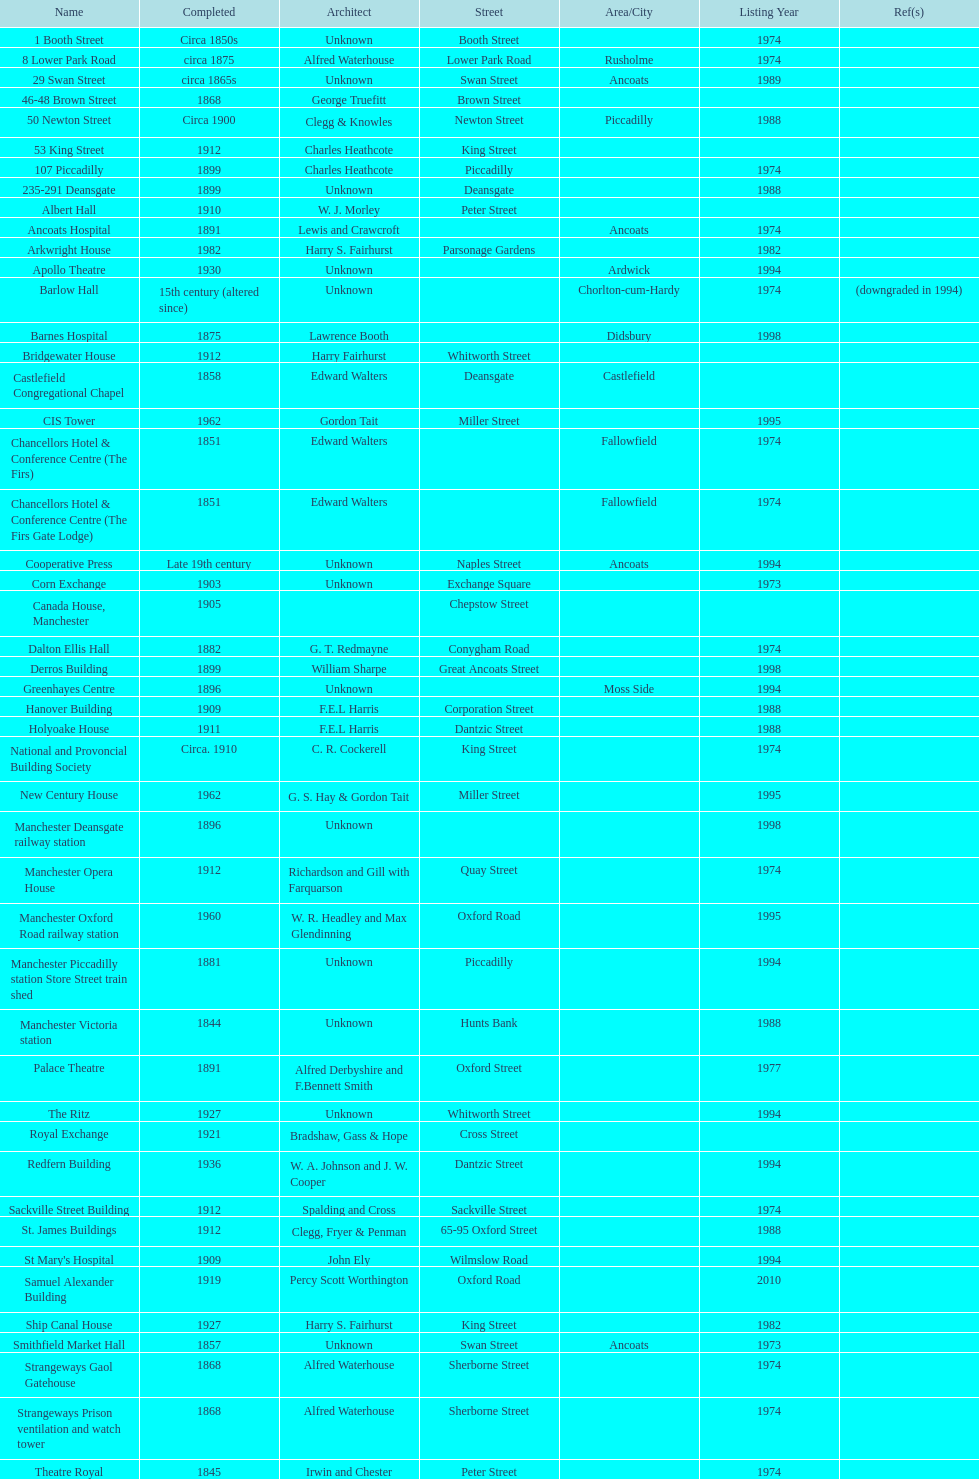How many buildings had alfred waterhouse as their architect? 3. 